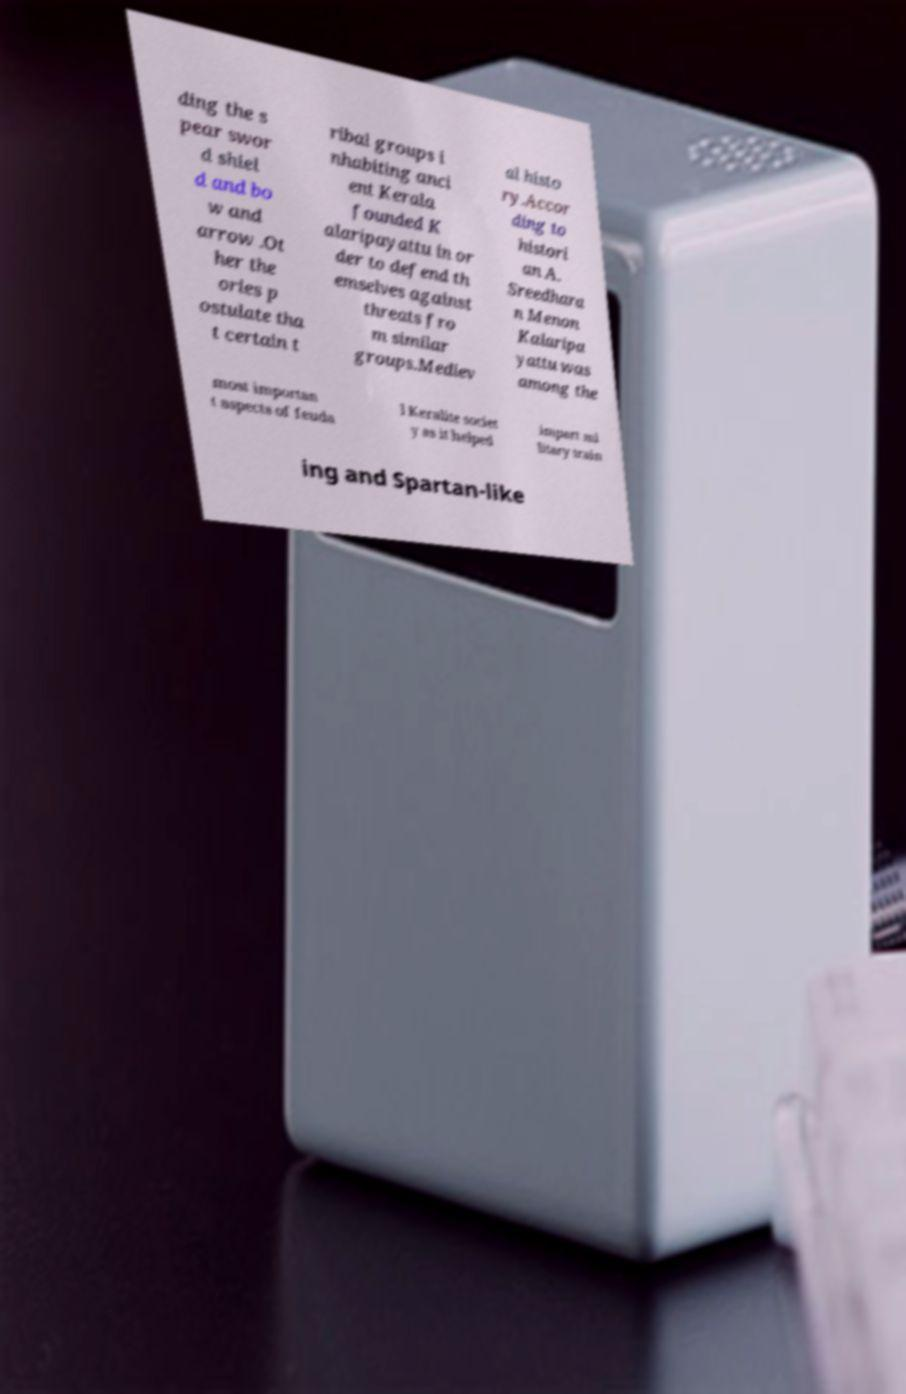Could you assist in decoding the text presented in this image and type it out clearly? ding the s pear swor d shiel d and bo w and arrow .Ot her the ories p ostulate tha t certain t ribal groups i nhabiting anci ent Kerala founded K alaripayattu in or der to defend th emselves against threats fro m similar groups.Mediev al histo ry.Accor ding to histori an A. Sreedhara n Menon Kalaripa yattu was among the most importan t aspects of feuda l Keralite societ y as it helped impart mi litary train ing and Spartan-like 